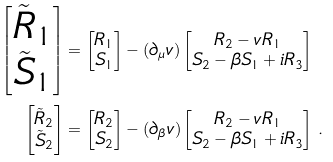Convert formula to latex. <formula><loc_0><loc_0><loc_500><loc_500>\begin{bmatrix} \tilde { R } _ { 1 } \\ \tilde { S } _ { 1 } \end{bmatrix} & = \begin{bmatrix} R _ { 1 } \\ S _ { 1 } \end{bmatrix} - ( \partial _ { \mu } v ) \begin{bmatrix} R _ { 2 } - v R _ { 1 } \\ S _ { 2 } - \beta S _ { 1 } + i R _ { 3 } \end{bmatrix} \\ \begin{bmatrix} \tilde { R } _ { 2 } \\ \tilde { S } _ { 2 } \end{bmatrix} & = \begin{bmatrix} R _ { 2 } \\ S _ { 2 } \end{bmatrix} - ( \partial _ { \beta } v ) \begin{bmatrix} R _ { 2 } - v R _ { 1 } \\ S _ { 2 } - \beta S _ { 1 } + i R _ { 3 } \end{bmatrix} \, .</formula> 